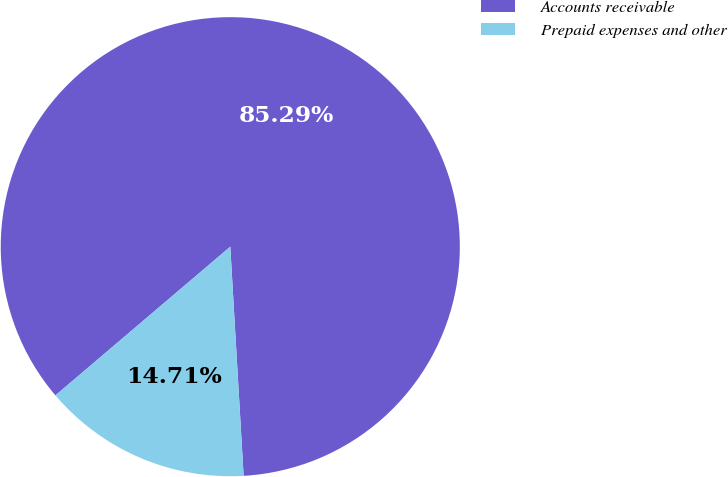<chart> <loc_0><loc_0><loc_500><loc_500><pie_chart><fcel>Accounts receivable<fcel>Prepaid expenses and other<nl><fcel>85.29%<fcel>14.71%<nl></chart> 